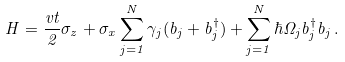<formula> <loc_0><loc_0><loc_500><loc_500>H = \frac { v t } { 2 } \sigma _ { z } + \sigma _ { x } \sum _ { j = 1 } ^ { N } \gamma _ { j } ( b _ { j } + b _ { j } ^ { \dagger } ) + \sum _ { j = 1 } ^ { N } \hbar { \Omega } _ { j } b _ { j } ^ { \dagger } b _ { j } \, .</formula> 